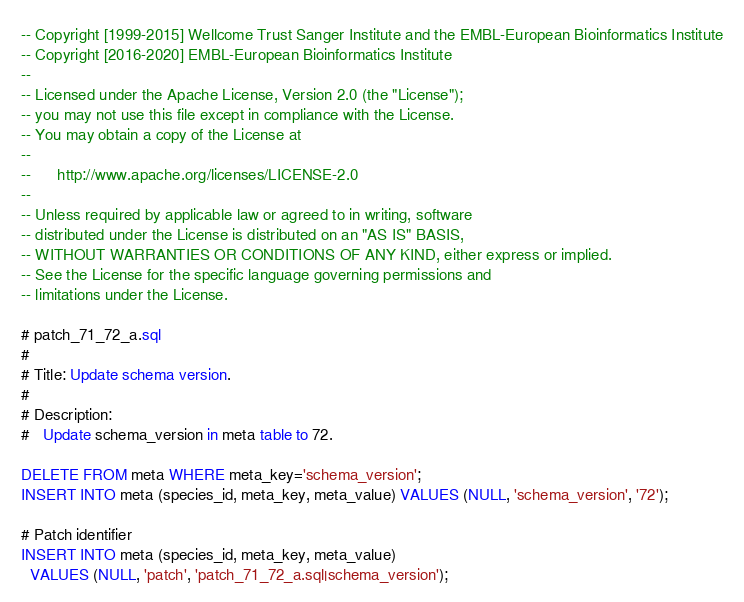<code> <loc_0><loc_0><loc_500><loc_500><_SQL_>-- Copyright [1999-2015] Wellcome Trust Sanger Institute and the EMBL-European Bioinformatics Institute
-- Copyright [2016-2020] EMBL-European Bioinformatics Institute
-- 
-- Licensed under the Apache License, Version 2.0 (the "License");
-- you may not use this file except in compliance with the License.
-- You may obtain a copy of the License at
-- 
--      http://www.apache.org/licenses/LICENSE-2.0
-- 
-- Unless required by applicable law or agreed to in writing, software
-- distributed under the License is distributed on an "AS IS" BASIS,
-- WITHOUT WARRANTIES OR CONDITIONS OF ANY KIND, either express or implied.
-- See the License for the specific language governing permissions and
-- limitations under the License.

# patch_71_72_a.sql
#
# Title: Update schema version.
#
# Description:
#   Update schema_version in meta table to 72.

DELETE FROM meta WHERE meta_key='schema_version';
INSERT INTO meta (species_id, meta_key, meta_value) VALUES (NULL, 'schema_version', '72');

# Patch identifier
INSERT INTO meta (species_id, meta_key, meta_value)
  VALUES (NULL, 'patch', 'patch_71_72_a.sql|schema_version');
</code> 